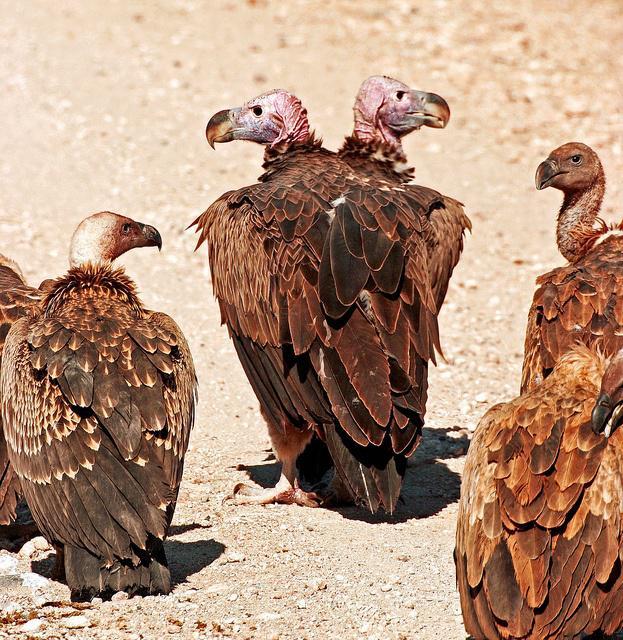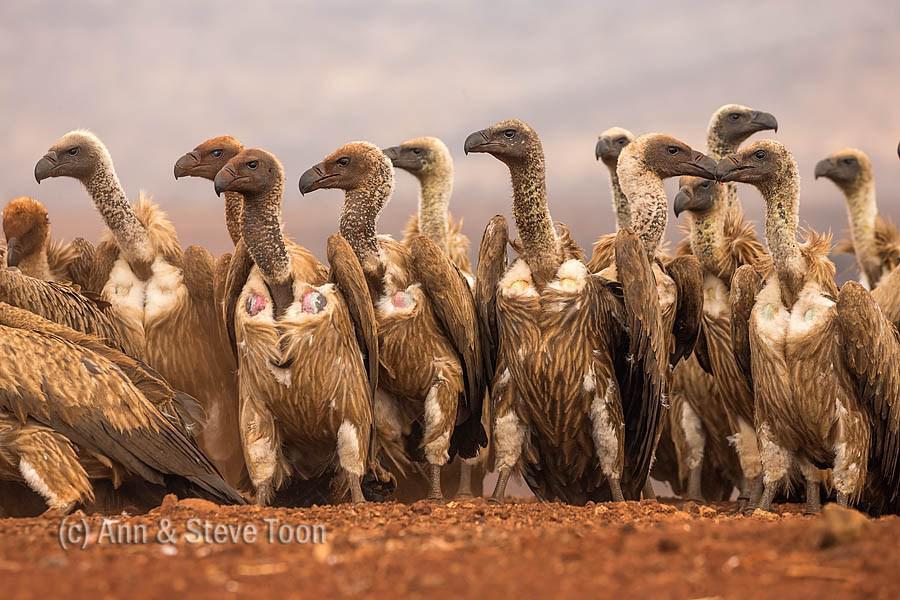The first image is the image on the left, the second image is the image on the right. Given the left and right images, does the statement "Overlapping vultures face opposite directions in the center of one image, which has a brown background." hold true? Answer yes or no. Yes. The first image is the image on the left, the second image is the image on the right. Evaluate the accuracy of this statement regarding the images: "One of the birds appears to have two heads in one of the images.". Is it true? Answer yes or no. Yes. 